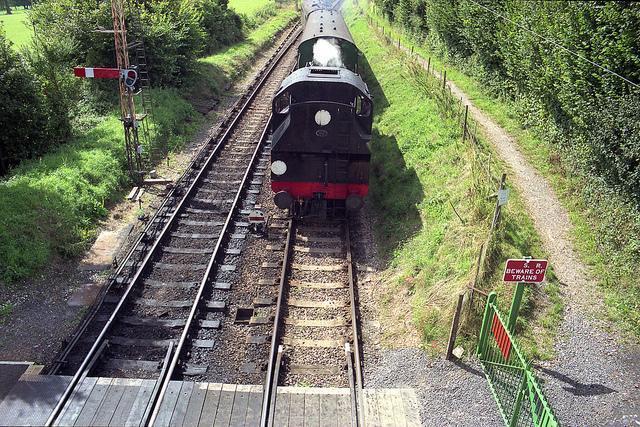How many people on the path?
Give a very brief answer. 0. 